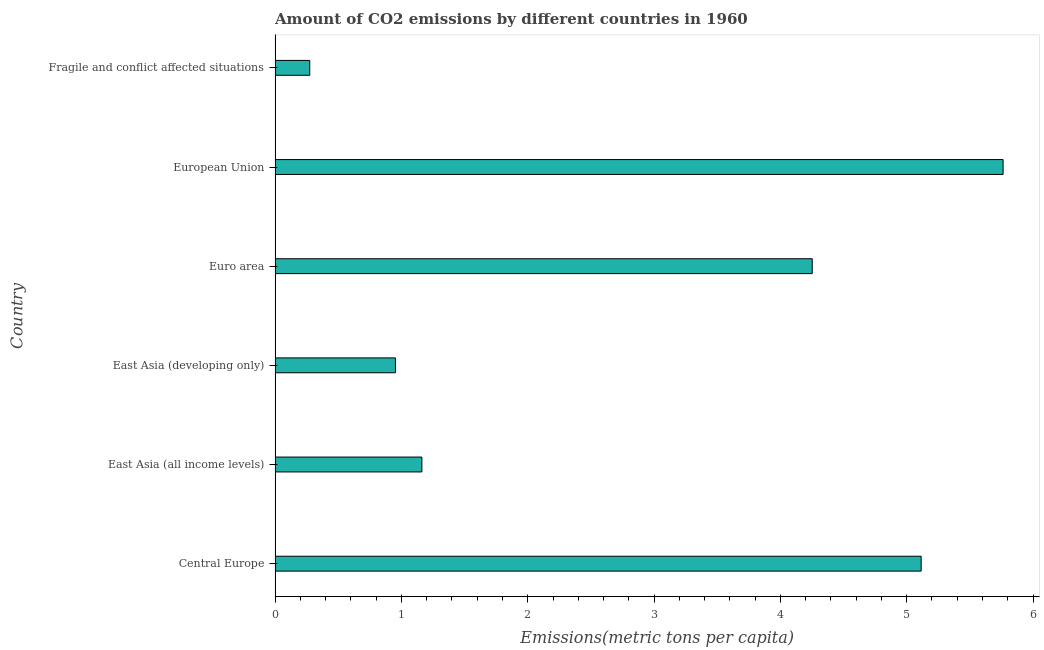Does the graph contain any zero values?
Your answer should be very brief. No. Does the graph contain grids?
Your response must be concise. No. What is the title of the graph?
Offer a very short reply. Amount of CO2 emissions by different countries in 1960. What is the label or title of the X-axis?
Your response must be concise. Emissions(metric tons per capita). What is the amount of co2 emissions in East Asia (developing only)?
Give a very brief answer. 0.95. Across all countries, what is the maximum amount of co2 emissions?
Your answer should be very brief. 5.76. Across all countries, what is the minimum amount of co2 emissions?
Provide a short and direct response. 0.27. In which country was the amount of co2 emissions maximum?
Keep it short and to the point. European Union. In which country was the amount of co2 emissions minimum?
Make the answer very short. Fragile and conflict affected situations. What is the sum of the amount of co2 emissions?
Provide a short and direct response. 17.52. What is the difference between the amount of co2 emissions in East Asia (all income levels) and European Union?
Offer a terse response. -4.6. What is the average amount of co2 emissions per country?
Your answer should be very brief. 2.92. What is the median amount of co2 emissions?
Make the answer very short. 2.71. What is the ratio of the amount of co2 emissions in East Asia (developing only) to that in Fragile and conflict affected situations?
Provide a short and direct response. 3.47. Is the amount of co2 emissions in East Asia (all income levels) less than that in European Union?
Your answer should be compact. Yes. Is the difference between the amount of co2 emissions in Central Europe and Fragile and conflict affected situations greater than the difference between any two countries?
Your response must be concise. No. What is the difference between the highest and the second highest amount of co2 emissions?
Provide a succinct answer. 0.65. What is the difference between the highest and the lowest amount of co2 emissions?
Make the answer very short. 5.49. In how many countries, is the amount of co2 emissions greater than the average amount of co2 emissions taken over all countries?
Ensure brevity in your answer.  3. How many bars are there?
Provide a succinct answer. 6. How many countries are there in the graph?
Provide a succinct answer. 6. What is the Emissions(metric tons per capita) in Central Europe?
Keep it short and to the point. 5.11. What is the Emissions(metric tons per capita) in East Asia (all income levels)?
Ensure brevity in your answer.  1.16. What is the Emissions(metric tons per capita) of East Asia (developing only)?
Keep it short and to the point. 0.95. What is the Emissions(metric tons per capita) in Euro area?
Your response must be concise. 4.25. What is the Emissions(metric tons per capita) in European Union?
Your answer should be very brief. 5.76. What is the Emissions(metric tons per capita) of Fragile and conflict affected situations?
Your answer should be very brief. 0.27. What is the difference between the Emissions(metric tons per capita) in Central Europe and East Asia (all income levels)?
Your answer should be compact. 3.95. What is the difference between the Emissions(metric tons per capita) in Central Europe and East Asia (developing only)?
Give a very brief answer. 4.16. What is the difference between the Emissions(metric tons per capita) in Central Europe and Euro area?
Ensure brevity in your answer.  0.86. What is the difference between the Emissions(metric tons per capita) in Central Europe and European Union?
Provide a short and direct response. -0.65. What is the difference between the Emissions(metric tons per capita) in Central Europe and Fragile and conflict affected situations?
Your response must be concise. 4.84. What is the difference between the Emissions(metric tons per capita) in East Asia (all income levels) and East Asia (developing only)?
Your answer should be very brief. 0.21. What is the difference between the Emissions(metric tons per capita) in East Asia (all income levels) and Euro area?
Provide a short and direct response. -3.09. What is the difference between the Emissions(metric tons per capita) in East Asia (all income levels) and European Union?
Offer a terse response. -4.6. What is the difference between the Emissions(metric tons per capita) in East Asia (all income levels) and Fragile and conflict affected situations?
Offer a terse response. 0.89. What is the difference between the Emissions(metric tons per capita) in East Asia (developing only) and Euro area?
Your response must be concise. -3.3. What is the difference between the Emissions(metric tons per capita) in East Asia (developing only) and European Union?
Keep it short and to the point. -4.81. What is the difference between the Emissions(metric tons per capita) in East Asia (developing only) and Fragile and conflict affected situations?
Make the answer very short. 0.68. What is the difference between the Emissions(metric tons per capita) in Euro area and European Union?
Your answer should be compact. -1.51. What is the difference between the Emissions(metric tons per capita) in Euro area and Fragile and conflict affected situations?
Your answer should be compact. 3.98. What is the difference between the Emissions(metric tons per capita) in European Union and Fragile and conflict affected situations?
Ensure brevity in your answer.  5.49. What is the ratio of the Emissions(metric tons per capita) in Central Europe to that in East Asia (all income levels)?
Your response must be concise. 4.4. What is the ratio of the Emissions(metric tons per capita) in Central Europe to that in East Asia (developing only)?
Your response must be concise. 5.37. What is the ratio of the Emissions(metric tons per capita) in Central Europe to that in Euro area?
Give a very brief answer. 1.2. What is the ratio of the Emissions(metric tons per capita) in Central Europe to that in European Union?
Provide a short and direct response. 0.89. What is the ratio of the Emissions(metric tons per capita) in Central Europe to that in Fragile and conflict affected situations?
Your response must be concise. 18.64. What is the ratio of the Emissions(metric tons per capita) in East Asia (all income levels) to that in East Asia (developing only)?
Your answer should be very brief. 1.22. What is the ratio of the Emissions(metric tons per capita) in East Asia (all income levels) to that in Euro area?
Provide a short and direct response. 0.27. What is the ratio of the Emissions(metric tons per capita) in East Asia (all income levels) to that in European Union?
Your response must be concise. 0.2. What is the ratio of the Emissions(metric tons per capita) in East Asia (all income levels) to that in Fragile and conflict affected situations?
Your answer should be very brief. 4.23. What is the ratio of the Emissions(metric tons per capita) in East Asia (developing only) to that in Euro area?
Your answer should be compact. 0.22. What is the ratio of the Emissions(metric tons per capita) in East Asia (developing only) to that in European Union?
Ensure brevity in your answer.  0.17. What is the ratio of the Emissions(metric tons per capita) in East Asia (developing only) to that in Fragile and conflict affected situations?
Your response must be concise. 3.47. What is the ratio of the Emissions(metric tons per capita) in Euro area to that in European Union?
Your response must be concise. 0.74. What is the ratio of the Emissions(metric tons per capita) in Euro area to that in Fragile and conflict affected situations?
Provide a succinct answer. 15.49. What is the ratio of the Emissions(metric tons per capita) in European Union to that in Fragile and conflict affected situations?
Provide a succinct answer. 21. 